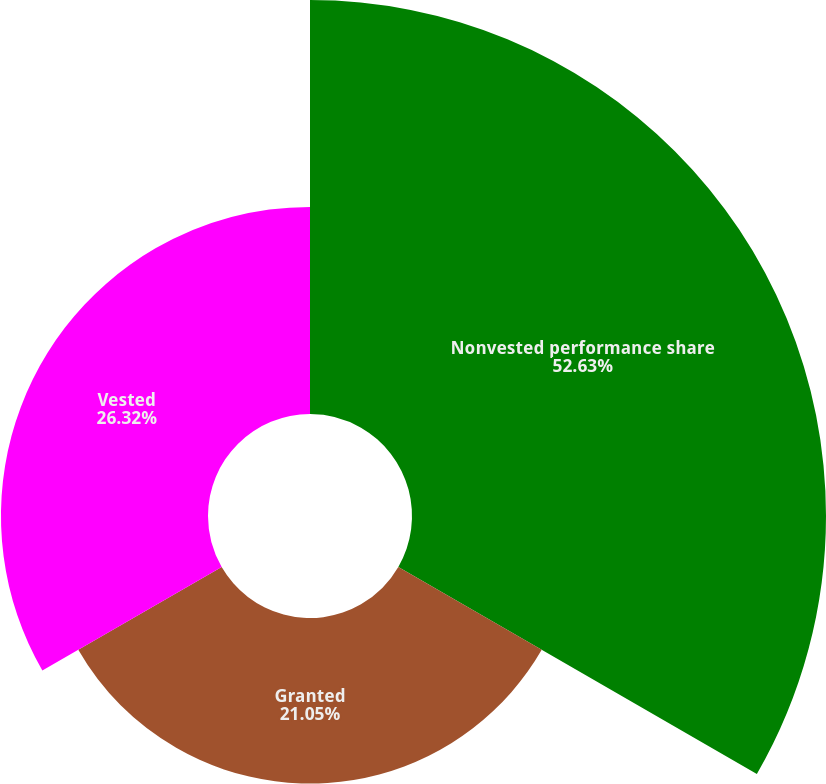Convert chart to OTSL. <chart><loc_0><loc_0><loc_500><loc_500><pie_chart><fcel>Nonvested performance share<fcel>Granted<fcel>Vested<nl><fcel>52.63%<fcel>21.05%<fcel>26.32%<nl></chart> 